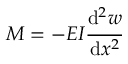<formula> <loc_0><loc_0><loc_500><loc_500>M = - E I { \cfrac { d ^ { 2 } w } { d x ^ { 2 } } }</formula> 